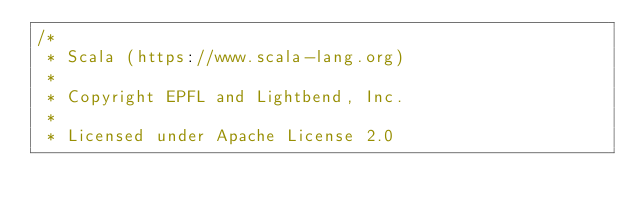<code> <loc_0><loc_0><loc_500><loc_500><_Scala_>/*
 * Scala (https://www.scala-lang.org)
 *
 * Copyright EPFL and Lightbend, Inc.
 *
 * Licensed under Apache License 2.0</code> 